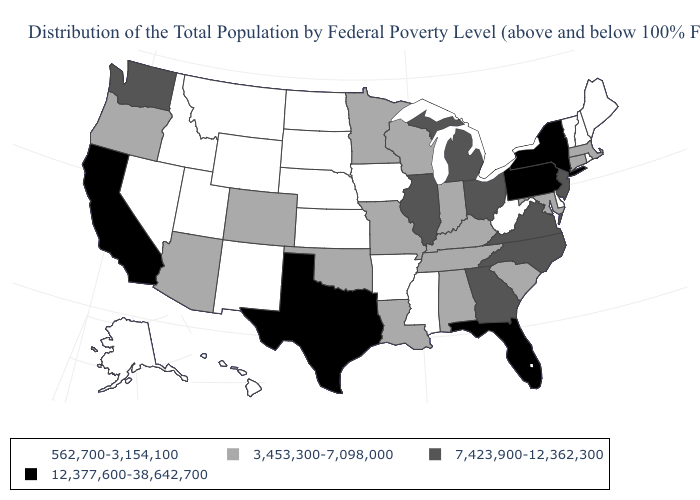What is the value of Ohio?
Be succinct. 7,423,900-12,362,300. What is the value of Tennessee?
Give a very brief answer. 3,453,300-7,098,000. Name the states that have a value in the range 562,700-3,154,100?
Be succinct. Alaska, Arkansas, Delaware, Hawaii, Idaho, Iowa, Kansas, Maine, Mississippi, Montana, Nebraska, Nevada, New Hampshire, New Mexico, North Dakota, Rhode Island, South Dakota, Utah, Vermont, West Virginia, Wyoming. What is the highest value in the USA?
Be succinct. 12,377,600-38,642,700. Does Hawaii have the lowest value in the West?
Concise answer only. Yes. What is the lowest value in states that border Illinois?
Give a very brief answer. 562,700-3,154,100. Name the states that have a value in the range 562,700-3,154,100?
Keep it brief. Alaska, Arkansas, Delaware, Hawaii, Idaho, Iowa, Kansas, Maine, Mississippi, Montana, Nebraska, Nevada, New Hampshire, New Mexico, North Dakota, Rhode Island, South Dakota, Utah, Vermont, West Virginia, Wyoming. What is the value of Massachusetts?
Give a very brief answer. 3,453,300-7,098,000. Does West Virginia have a lower value than Virginia?
Keep it brief. Yes. What is the highest value in the Northeast ?
Answer briefly. 12,377,600-38,642,700. Is the legend a continuous bar?
Write a very short answer. No. Is the legend a continuous bar?
Write a very short answer. No. How many symbols are there in the legend?
Be succinct. 4. Does Maryland have the same value as Rhode Island?
Answer briefly. No. Does the map have missing data?
Answer briefly. No. 